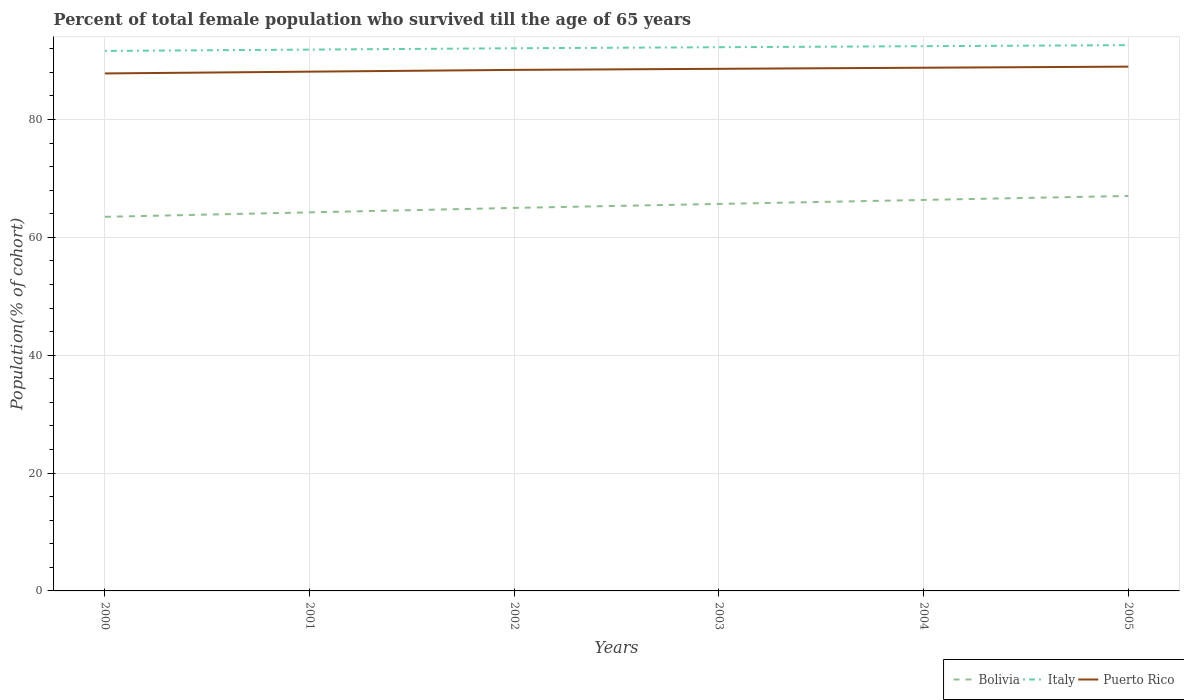Across all years, what is the maximum percentage of total female population who survived till the age of 65 years in Puerto Rico?
Provide a short and direct response. 87.82. In which year was the percentage of total female population who survived till the age of 65 years in Puerto Rico maximum?
Your response must be concise. 2000. What is the total percentage of total female population who survived till the age of 65 years in Puerto Rico in the graph?
Offer a terse response. -0.3. What is the difference between the highest and the second highest percentage of total female population who survived till the age of 65 years in Italy?
Ensure brevity in your answer.  0.98. How many years are there in the graph?
Your answer should be compact. 6. What is the difference between two consecutive major ticks on the Y-axis?
Provide a short and direct response. 20. Are the values on the major ticks of Y-axis written in scientific E-notation?
Offer a terse response. No. Does the graph contain grids?
Your answer should be very brief. Yes. Where does the legend appear in the graph?
Keep it short and to the point. Bottom right. How many legend labels are there?
Your response must be concise. 3. How are the legend labels stacked?
Make the answer very short. Horizontal. What is the title of the graph?
Your answer should be very brief. Percent of total female population who survived till the age of 65 years. Does "Latin America(developing only)" appear as one of the legend labels in the graph?
Provide a succinct answer. No. What is the label or title of the Y-axis?
Keep it short and to the point. Population(% of cohort). What is the Population(% of cohort) of Bolivia in 2000?
Offer a very short reply. 63.49. What is the Population(% of cohort) in Italy in 2000?
Keep it short and to the point. 91.64. What is the Population(% of cohort) of Puerto Rico in 2000?
Keep it short and to the point. 87.82. What is the Population(% of cohort) in Bolivia in 2001?
Keep it short and to the point. 64.25. What is the Population(% of cohort) of Italy in 2001?
Your answer should be compact. 91.87. What is the Population(% of cohort) of Puerto Rico in 2001?
Keep it short and to the point. 88.12. What is the Population(% of cohort) of Bolivia in 2002?
Your answer should be compact. 65. What is the Population(% of cohort) of Italy in 2002?
Make the answer very short. 92.1. What is the Population(% of cohort) of Puerto Rico in 2002?
Ensure brevity in your answer.  88.42. What is the Population(% of cohort) in Bolivia in 2003?
Provide a succinct answer. 65.68. What is the Population(% of cohort) in Italy in 2003?
Your answer should be very brief. 92.27. What is the Population(% of cohort) of Puerto Rico in 2003?
Your response must be concise. 88.61. What is the Population(% of cohort) in Bolivia in 2004?
Offer a very short reply. 66.35. What is the Population(% of cohort) in Italy in 2004?
Your response must be concise. 92.45. What is the Population(% of cohort) in Puerto Rico in 2004?
Offer a terse response. 88.79. What is the Population(% of cohort) in Bolivia in 2005?
Your answer should be very brief. 67.03. What is the Population(% of cohort) of Italy in 2005?
Provide a short and direct response. 92.62. What is the Population(% of cohort) in Puerto Rico in 2005?
Keep it short and to the point. 88.98. Across all years, what is the maximum Population(% of cohort) in Bolivia?
Your response must be concise. 67.03. Across all years, what is the maximum Population(% of cohort) of Italy?
Your response must be concise. 92.62. Across all years, what is the maximum Population(% of cohort) of Puerto Rico?
Your response must be concise. 88.98. Across all years, what is the minimum Population(% of cohort) in Bolivia?
Offer a very short reply. 63.49. Across all years, what is the minimum Population(% of cohort) in Italy?
Make the answer very short. 91.64. Across all years, what is the minimum Population(% of cohort) of Puerto Rico?
Provide a short and direct response. 87.82. What is the total Population(% of cohort) in Bolivia in the graph?
Provide a short and direct response. 391.8. What is the total Population(% of cohort) of Italy in the graph?
Keep it short and to the point. 552.95. What is the total Population(% of cohort) in Puerto Rico in the graph?
Provide a short and direct response. 530.75. What is the difference between the Population(% of cohort) in Bolivia in 2000 and that in 2001?
Your answer should be very brief. -0.76. What is the difference between the Population(% of cohort) of Italy in 2000 and that in 2001?
Provide a short and direct response. -0.23. What is the difference between the Population(% of cohort) in Puerto Rico in 2000 and that in 2001?
Provide a succinct answer. -0.3. What is the difference between the Population(% of cohort) in Bolivia in 2000 and that in 2002?
Give a very brief answer. -1.51. What is the difference between the Population(% of cohort) of Italy in 2000 and that in 2002?
Keep it short and to the point. -0.45. What is the difference between the Population(% of cohort) of Puerto Rico in 2000 and that in 2002?
Keep it short and to the point. -0.6. What is the difference between the Population(% of cohort) of Bolivia in 2000 and that in 2003?
Make the answer very short. -2.19. What is the difference between the Population(% of cohort) of Italy in 2000 and that in 2003?
Offer a terse response. -0.63. What is the difference between the Population(% of cohort) in Puerto Rico in 2000 and that in 2003?
Provide a succinct answer. -0.78. What is the difference between the Population(% of cohort) in Bolivia in 2000 and that in 2004?
Offer a terse response. -2.87. What is the difference between the Population(% of cohort) in Italy in 2000 and that in 2004?
Provide a short and direct response. -0.81. What is the difference between the Population(% of cohort) in Puerto Rico in 2000 and that in 2004?
Your answer should be compact. -0.97. What is the difference between the Population(% of cohort) in Bolivia in 2000 and that in 2005?
Ensure brevity in your answer.  -3.54. What is the difference between the Population(% of cohort) in Italy in 2000 and that in 2005?
Your answer should be very brief. -0.98. What is the difference between the Population(% of cohort) in Puerto Rico in 2000 and that in 2005?
Provide a succinct answer. -1.15. What is the difference between the Population(% of cohort) of Bolivia in 2001 and that in 2002?
Your response must be concise. -0.76. What is the difference between the Population(% of cohort) in Italy in 2001 and that in 2002?
Keep it short and to the point. -0.23. What is the difference between the Population(% of cohort) in Puerto Rico in 2001 and that in 2002?
Offer a very short reply. -0.3. What is the difference between the Population(% of cohort) of Bolivia in 2001 and that in 2003?
Provide a succinct answer. -1.43. What is the difference between the Population(% of cohort) in Italy in 2001 and that in 2003?
Offer a terse response. -0.4. What is the difference between the Population(% of cohort) of Puerto Rico in 2001 and that in 2003?
Your answer should be very brief. -0.48. What is the difference between the Population(% of cohort) of Bolivia in 2001 and that in 2004?
Your response must be concise. -2.11. What is the difference between the Population(% of cohort) in Italy in 2001 and that in 2004?
Your answer should be very brief. -0.58. What is the difference between the Population(% of cohort) of Puerto Rico in 2001 and that in 2004?
Your answer should be very brief. -0.67. What is the difference between the Population(% of cohort) of Bolivia in 2001 and that in 2005?
Provide a short and direct response. -2.79. What is the difference between the Population(% of cohort) of Italy in 2001 and that in 2005?
Offer a very short reply. -0.75. What is the difference between the Population(% of cohort) in Puerto Rico in 2001 and that in 2005?
Keep it short and to the point. -0.85. What is the difference between the Population(% of cohort) of Bolivia in 2002 and that in 2003?
Make the answer very short. -0.68. What is the difference between the Population(% of cohort) in Italy in 2002 and that in 2003?
Your answer should be compact. -0.18. What is the difference between the Population(% of cohort) of Puerto Rico in 2002 and that in 2003?
Provide a succinct answer. -0.18. What is the difference between the Population(% of cohort) in Bolivia in 2002 and that in 2004?
Make the answer very short. -1.35. What is the difference between the Population(% of cohort) in Italy in 2002 and that in 2004?
Provide a short and direct response. -0.35. What is the difference between the Population(% of cohort) in Puerto Rico in 2002 and that in 2004?
Your answer should be very brief. -0.37. What is the difference between the Population(% of cohort) of Bolivia in 2002 and that in 2005?
Ensure brevity in your answer.  -2.03. What is the difference between the Population(% of cohort) in Italy in 2002 and that in 2005?
Your response must be concise. -0.53. What is the difference between the Population(% of cohort) of Puerto Rico in 2002 and that in 2005?
Keep it short and to the point. -0.55. What is the difference between the Population(% of cohort) in Bolivia in 2003 and that in 2004?
Your response must be concise. -0.68. What is the difference between the Population(% of cohort) of Italy in 2003 and that in 2004?
Ensure brevity in your answer.  -0.18. What is the difference between the Population(% of cohort) of Puerto Rico in 2003 and that in 2004?
Your response must be concise. -0.18. What is the difference between the Population(% of cohort) of Bolivia in 2003 and that in 2005?
Your answer should be compact. -1.35. What is the difference between the Population(% of cohort) in Italy in 2003 and that in 2005?
Make the answer very short. -0.35. What is the difference between the Population(% of cohort) of Puerto Rico in 2003 and that in 2005?
Your response must be concise. -0.37. What is the difference between the Population(% of cohort) in Bolivia in 2004 and that in 2005?
Provide a succinct answer. -0.68. What is the difference between the Population(% of cohort) in Italy in 2004 and that in 2005?
Provide a short and direct response. -0.18. What is the difference between the Population(% of cohort) of Puerto Rico in 2004 and that in 2005?
Keep it short and to the point. -0.18. What is the difference between the Population(% of cohort) of Bolivia in 2000 and the Population(% of cohort) of Italy in 2001?
Your answer should be very brief. -28.38. What is the difference between the Population(% of cohort) in Bolivia in 2000 and the Population(% of cohort) in Puerto Rico in 2001?
Make the answer very short. -24.63. What is the difference between the Population(% of cohort) in Italy in 2000 and the Population(% of cohort) in Puerto Rico in 2001?
Give a very brief answer. 3.52. What is the difference between the Population(% of cohort) in Bolivia in 2000 and the Population(% of cohort) in Italy in 2002?
Offer a very short reply. -28.61. What is the difference between the Population(% of cohort) in Bolivia in 2000 and the Population(% of cohort) in Puerto Rico in 2002?
Your answer should be compact. -24.93. What is the difference between the Population(% of cohort) of Italy in 2000 and the Population(% of cohort) of Puerto Rico in 2002?
Provide a short and direct response. 3.22. What is the difference between the Population(% of cohort) in Bolivia in 2000 and the Population(% of cohort) in Italy in 2003?
Provide a short and direct response. -28.78. What is the difference between the Population(% of cohort) of Bolivia in 2000 and the Population(% of cohort) of Puerto Rico in 2003?
Your answer should be compact. -25.12. What is the difference between the Population(% of cohort) in Italy in 2000 and the Population(% of cohort) in Puerto Rico in 2003?
Keep it short and to the point. 3.03. What is the difference between the Population(% of cohort) in Bolivia in 2000 and the Population(% of cohort) in Italy in 2004?
Your answer should be compact. -28.96. What is the difference between the Population(% of cohort) of Bolivia in 2000 and the Population(% of cohort) of Puerto Rico in 2004?
Offer a terse response. -25.3. What is the difference between the Population(% of cohort) in Italy in 2000 and the Population(% of cohort) in Puerto Rico in 2004?
Your answer should be compact. 2.85. What is the difference between the Population(% of cohort) in Bolivia in 2000 and the Population(% of cohort) in Italy in 2005?
Provide a succinct answer. -29.13. What is the difference between the Population(% of cohort) in Bolivia in 2000 and the Population(% of cohort) in Puerto Rico in 2005?
Your answer should be compact. -25.49. What is the difference between the Population(% of cohort) of Italy in 2000 and the Population(% of cohort) of Puerto Rico in 2005?
Provide a succinct answer. 2.67. What is the difference between the Population(% of cohort) in Bolivia in 2001 and the Population(% of cohort) in Italy in 2002?
Your answer should be very brief. -27.85. What is the difference between the Population(% of cohort) in Bolivia in 2001 and the Population(% of cohort) in Puerto Rico in 2002?
Offer a terse response. -24.18. What is the difference between the Population(% of cohort) in Italy in 2001 and the Population(% of cohort) in Puerto Rico in 2002?
Your answer should be compact. 3.44. What is the difference between the Population(% of cohort) of Bolivia in 2001 and the Population(% of cohort) of Italy in 2003?
Your answer should be very brief. -28.03. What is the difference between the Population(% of cohort) of Bolivia in 2001 and the Population(% of cohort) of Puerto Rico in 2003?
Your answer should be compact. -24.36. What is the difference between the Population(% of cohort) in Italy in 2001 and the Population(% of cohort) in Puerto Rico in 2003?
Keep it short and to the point. 3.26. What is the difference between the Population(% of cohort) in Bolivia in 2001 and the Population(% of cohort) in Italy in 2004?
Make the answer very short. -28.2. What is the difference between the Population(% of cohort) of Bolivia in 2001 and the Population(% of cohort) of Puerto Rico in 2004?
Give a very brief answer. -24.55. What is the difference between the Population(% of cohort) of Italy in 2001 and the Population(% of cohort) of Puerto Rico in 2004?
Ensure brevity in your answer.  3.08. What is the difference between the Population(% of cohort) in Bolivia in 2001 and the Population(% of cohort) in Italy in 2005?
Provide a succinct answer. -28.38. What is the difference between the Population(% of cohort) in Bolivia in 2001 and the Population(% of cohort) in Puerto Rico in 2005?
Your answer should be compact. -24.73. What is the difference between the Population(% of cohort) of Italy in 2001 and the Population(% of cohort) of Puerto Rico in 2005?
Ensure brevity in your answer.  2.89. What is the difference between the Population(% of cohort) of Bolivia in 2002 and the Population(% of cohort) of Italy in 2003?
Provide a succinct answer. -27.27. What is the difference between the Population(% of cohort) of Bolivia in 2002 and the Population(% of cohort) of Puerto Rico in 2003?
Make the answer very short. -23.61. What is the difference between the Population(% of cohort) in Italy in 2002 and the Population(% of cohort) in Puerto Rico in 2003?
Your answer should be very brief. 3.49. What is the difference between the Population(% of cohort) in Bolivia in 2002 and the Population(% of cohort) in Italy in 2004?
Your response must be concise. -27.45. What is the difference between the Population(% of cohort) of Bolivia in 2002 and the Population(% of cohort) of Puerto Rico in 2004?
Your response must be concise. -23.79. What is the difference between the Population(% of cohort) of Italy in 2002 and the Population(% of cohort) of Puerto Rico in 2004?
Your response must be concise. 3.3. What is the difference between the Population(% of cohort) of Bolivia in 2002 and the Population(% of cohort) of Italy in 2005?
Your answer should be very brief. -27.62. What is the difference between the Population(% of cohort) in Bolivia in 2002 and the Population(% of cohort) in Puerto Rico in 2005?
Ensure brevity in your answer.  -23.97. What is the difference between the Population(% of cohort) of Italy in 2002 and the Population(% of cohort) of Puerto Rico in 2005?
Offer a terse response. 3.12. What is the difference between the Population(% of cohort) in Bolivia in 2003 and the Population(% of cohort) in Italy in 2004?
Ensure brevity in your answer.  -26.77. What is the difference between the Population(% of cohort) of Bolivia in 2003 and the Population(% of cohort) of Puerto Rico in 2004?
Give a very brief answer. -23.11. What is the difference between the Population(% of cohort) of Italy in 2003 and the Population(% of cohort) of Puerto Rico in 2004?
Keep it short and to the point. 3.48. What is the difference between the Population(% of cohort) of Bolivia in 2003 and the Population(% of cohort) of Italy in 2005?
Provide a succinct answer. -26.94. What is the difference between the Population(% of cohort) in Bolivia in 2003 and the Population(% of cohort) in Puerto Rico in 2005?
Offer a very short reply. -23.3. What is the difference between the Population(% of cohort) of Italy in 2003 and the Population(% of cohort) of Puerto Rico in 2005?
Provide a short and direct response. 3.3. What is the difference between the Population(% of cohort) in Bolivia in 2004 and the Population(% of cohort) in Italy in 2005?
Your answer should be very brief. -26.27. What is the difference between the Population(% of cohort) of Bolivia in 2004 and the Population(% of cohort) of Puerto Rico in 2005?
Your answer should be compact. -22.62. What is the difference between the Population(% of cohort) of Italy in 2004 and the Population(% of cohort) of Puerto Rico in 2005?
Give a very brief answer. 3.47. What is the average Population(% of cohort) in Bolivia per year?
Offer a very short reply. 65.3. What is the average Population(% of cohort) in Italy per year?
Ensure brevity in your answer.  92.16. What is the average Population(% of cohort) of Puerto Rico per year?
Keep it short and to the point. 88.46. In the year 2000, what is the difference between the Population(% of cohort) of Bolivia and Population(% of cohort) of Italy?
Make the answer very short. -28.15. In the year 2000, what is the difference between the Population(% of cohort) in Bolivia and Population(% of cohort) in Puerto Rico?
Keep it short and to the point. -24.33. In the year 2000, what is the difference between the Population(% of cohort) in Italy and Population(% of cohort) in Puerto Rico?
Your response must be concise. 3.82. In the year 2001, what is the difference between the Population(% of cohort) in Bolivia and Population(% of cohort) in Italy?
Your response must be concise. -27.62. In the year 2001, what is the difference between the Population(% of cohort) in Bolivia and Population(% of cohort) in Puerto Rico?
Make the answer very short. -23.88. In the year 2001, what is the difference between the Population(% of cohort) in Italy and Population(% of cohort) in Puerto Rico?
Offer a terse response. 3.74. In the year 2002, what is the difference between the Population(% of cohort) of Bolivia and Population(% of cohort) of Italy?
Offer a terse response. -27.09. In the year 2002, what is the difference between the Population(% of cohort) of Bolivia and Population(% of cohort) of Puerto Rico?
Keep it short and to the point. -23.42. In the year 2002, what is the difference between the Population(% of cohort) of Italy and Population(% of cohort) of Puerto Rico?
Your answer should be compact. 3.67. In the year 2003, what is the difference between the Population(% of cohort) in Bolivia and Population(% of cohort) in Italy?
Make the answer very short. -26.59. In the year 2003, what is the difference between the Population(% of cohort) of Bolivia and Population(% of cohort) of Puerto Rico?
Your answer should be very brief. -22.93. In the year 2003, what is the difference between the Population(% of cohort) in Italy and Population(% of cohort) in Puerto Rico?
Ensure brevity in your answer.  3.66. In the year 2004, what is the difference between the Population(% of cohort) of Bolivia and Population(% of cohort) of Italy?
Provide a succinct answer. -26.09. In the year 2004, what is the difference between the Population(% of cohort) of Bolivia and Population(% of cohort) of Puerto Rico?
Ensure brevity in your answer.  -22.44. In the year 2004, what is the difference between the Population(% of cohort) of Italy and Population(% of cohort) of Puerto Rico?
Ensure brevity in your answer.  3.65. In the year 2005, what is the difference between the Population(% of cohort) of Bolivia and Population(% of cohort) of Italy?
Your response must be concise. -25.59. In the year 2005, what is the difference between the Population(% of cohort) of Bolivia and Population(% of cohort) of Puerto Rico?
Keep it short and to the point. -21.94. In the year 2005, what is the difference between the Population(% of cohort) in Italy and Population(% of cohort) in Puerto Rico?
Your response must be concise. 3.65. What is the ratio of the Population(% of cohort) in Italy in 2000 to that in 2001?
Make the answer very short. 1. What is the ratio of the Population(% of cohort) of Puerto Rico in 2000 to that in 2001?
Offer a very short reply. 1. What is the ratio of the Population(% of cohort) of Bolivia in 2000 to that in 2002?
Make the answer very short. 0.98. What is the ratio of the Population(% of cohort) in Italy in 2000 to that in 2002?
Your answer should be compact. 1. What is the ratio of the Population(% of cohort) in Puerto Rico in 2000 to that in 2002?
Offer a terse response. 0.99. What is the ratio of the Population(% of cohort) in Bolivia in 2000 to that in 2003?
Give a very brief answer. 0.97. What is the ratio of the Population(% of cohort) in Bolivia in 2000 to that in 2004?
Give a very brief answer. 0.96. What is the ratio of the Population(% of cohort) in Italy in 2000 to that in 2004?
Offer a terse response. 0.99. What is the ratio of the Population(% of cohort) in Bolivia in 2000 to that in 2005?
Your answer should be very brief. 0.95. What is the ratio of the Population(% of cohort) of Puerto Rico in 2000 to that in 2005?
Your answer should be compact. 0.99. What is the ratio of the Population(% of cohort) in Bolivia in 2001 to that in 2002?
Your response must be concise. 0.99. What is the ratio of the Population(% of cohort) of Italy in 2001 to that in 2002?
Keep it short and to the point. 1. What is the ratio of the Population(% of cohort) of Puerto Rico in 2001 to that in 2002?
Give a very brief answer. 1. What is the ratio of the Population(% of cohort) of Bolivia in 2001 to that in 2003?
Your answer should be very brief. 0.98. What is the ratio of the Population(% of cohort) of Bolivia in 2001 to that in 2004?
Make the answer very short. 0.97. What is the ratio of the Population(% of cohort) in Bolivia in 2001 to that in 2005?
Provide a succinct answer. 0.96. What is the ratio of the Population(% of cohort) in Italy in 2001 to that in 2005?
Offer a terse response. 0.99. What is the ratio of the Population(% of cohort) of Bolivia in 2002 to that in 2003?
Your response must be concise. 0.99. What is the ratio of the Population(% of cohort) in Bolivia in 2002 to that in 2004?
Ensure brevity in your answer.  0.98. What is the ratio of the Population(% of cohort) in Puerto Rico in 2002 to that in 2004?
Offer a terse response. 1. What is the ratio of the Population(% of cohort) of Bolivia in 2002 to that in 2005?
Your answer should be very brief. 0.97. What is the ratio of the Population(% of cohort) of Italy in 2002 to that in 2005?
Offer a very short reply. 0.99. What is the ratio of the Population(% of cohort) of Puerto Rico in 2002 to that in 2005?
Your answer should be very brief. 0.99. What is the ratio of the Population(% of cohort) in Italy in 2003 to that in 2004?
Ensure brevity in your answer.  1. What is the ratio of the Population(% of cohort) in Puerto Rico in 2003 to that in 2004?
Ensure brevity in your answer.  1. What is the ratio of the Population(% of cohort) of Bolivia in 2003 to that in 2005?
Your response must be concise. 0.98. What is the ratio of the Population(% of cohort) of Italy in 2003 to that in 2005?
Offer a very short reply. 1. What is the ratio of the Population(% of cohort) in Bolivia in 2004 to that in 2005?
Your response must be concise. 0.99. What is the ratio of the Population(% of cohort) of Puerto Rico in 2004 to that in 2005?
Provide a succinct answer. 1. What is the difference between the highest and the second highest Population(% of cohort) in Bolivia?
Your answer should be very brief. 0.68. What is the difference between the highest and the second highest Population(% of cohort) in Italy?
Your answer should be compact. 0.18. What is the difference between the highest and the second highest Population(% of cohort) of Puerto Rico?
Your answer should be compact. 0.18. What is the difference between the highest and the lowest Population(% of cohort) of Bolivia?
Ensure brevity in your answer.  3.54. What is the difference between the highest and the lowest Population(% of cohort) of Italy?
Keep it short and to the point. 0.98. What is the difference between the highest and the lowest Population(% of cohort) in Puerto Rico?
Your response must be concise. 1.15. 